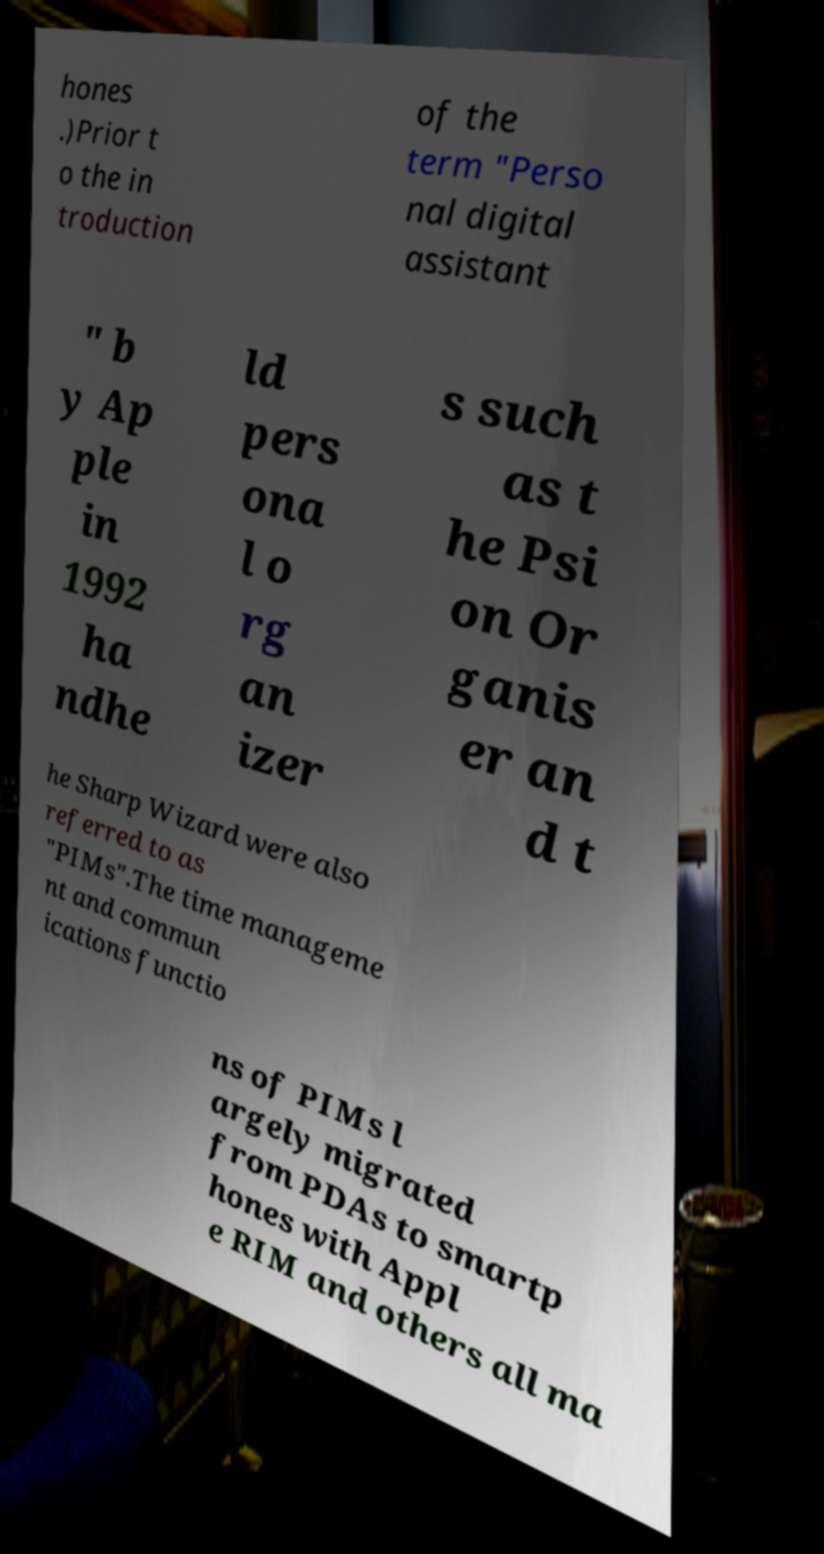Please identify and transcribe the text found in this image. hones .)Prior t o the in troduction of the term "Perso nal digital assistant " b y Ap ple in 1992 ha ndhe ld pers ona l o rg an izer s such as t he Psi on Or ganis er an d t he Sharp Wizard were also referred to as "PIMs".The time manageme nt and commun ications functio ns of PIMs l argely migrated from PDAs to smartp hones with Appl e RIM and others all ma 